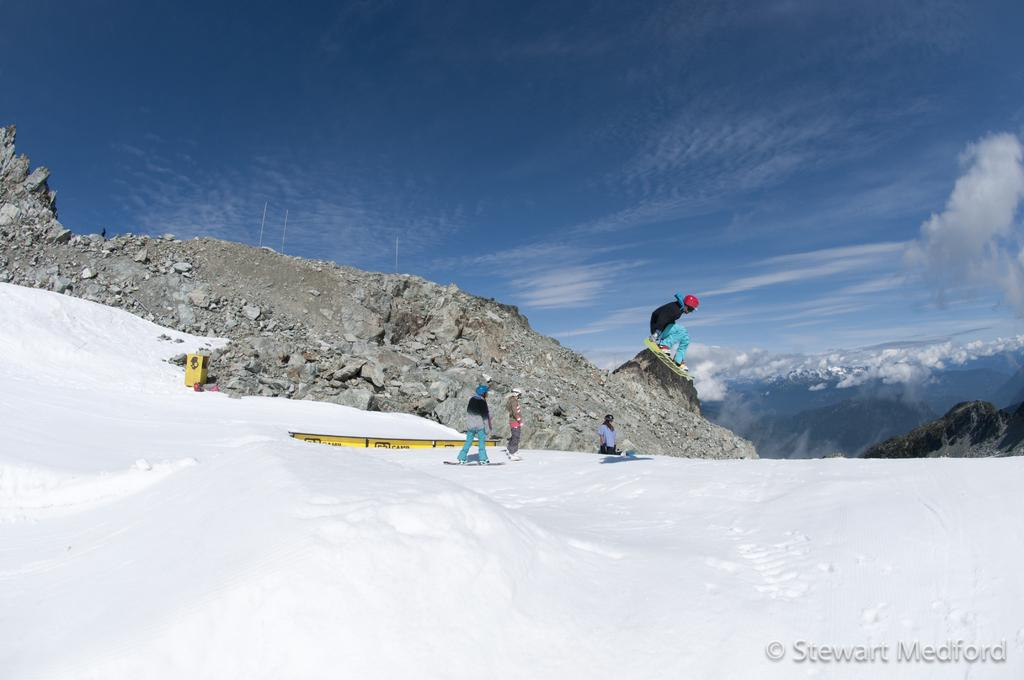Who or what can be seen in the image? There are people in the image. What are the people doing in the image? The people are skating. Where are the people skating in the image? The skating is taking place on a snow mountain. What is the color of the sky in the image? The sky is blue in the image. What type of vest can be seen on the side of the snow mountain in the image? There is no vest present on the side of the snow mountain in the image. 